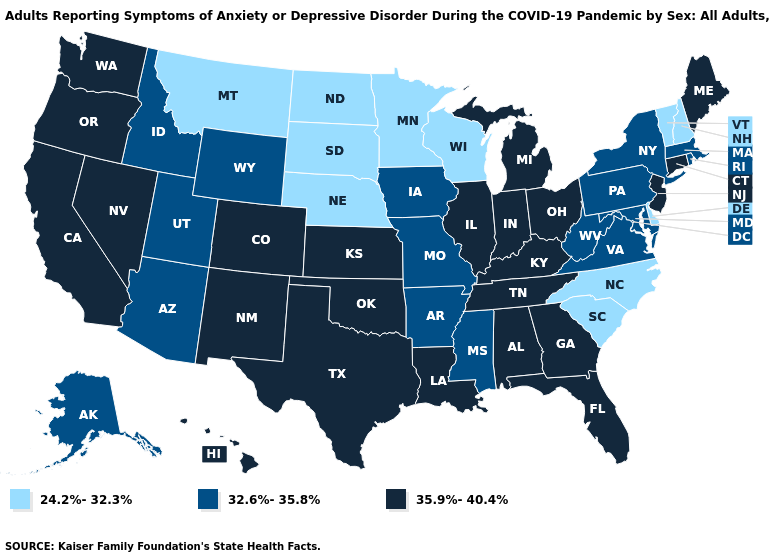Among the states that border Virginia , does Tennessee have the highest value?
Answer briefly. Yes. Does Oklahoma have the lowest value in the USA?
Be succinct. No. Among the states that border Kentucky , does West Virginia have the highest value?
Quick response, please. No. Name the states that have a value in the range 24.2%-32.3%?
Quick response, please. Delaware, Minnesota, Montana, Nebraska, New Hampshire, North Carolina, North Dakota, South Carolina, South Dakota, Vermont, Wisconsin. Name the states that have a value in the range 24.2%-32.3%?
Answer briefly. Delaware, Minnesota, Montana, Nebraska, New Hampshire, North Carolina, North Dakota, South Carolina, South Dakota, Vermont, Wisconsin. Does Indiana have the highest value in the MidWest?
Write a very short answer. Yes. What is the value of Ohio?
Quick response, please. 35.9%-40.4%. Does Kentucky have the same value as Rhode Island?
Keep it brief. No. Is the legend a continuous bar?
Be succinct. No. What is the value of South Carolina?
Short answer required. 24.2%-32.3%. Name the states that have a value in the range 32.6%-35.8%?
Keep it brief. Alaska, Arizona, Arkansas, Idaho, Iowa, Maryland, Massachusetts, Mississippi, Missouri, New York, Pennsylvania, Rhode Island, Utah, Virginia, West Virginia, Wyoming. Does North Dakota have the same value as Iowa?
Keep it brief. No. Name the states that have a value in the range 24.2%-32.3%?
Write a very short answer. Delaware, Minnesota, Montana, Nebraska, New Hampshire, North Carolina, North Dakota, South Carolina, South Dakota, Vermont, Wisconsin. What is the lowest value in the MidWest?
Concise answer only. 24.2%-32.3%. Name the states that have a value in the range 32.6%-35.8%?
Quick response, please. Alaska, Arizona, Arkansas, Idaho, Iowa, Maryland, Massachusetts, Mississippi, Missouri, New York, Pennsylvania, Rhode Island, Utah, Virginia, West Virginia, Wyoming. 